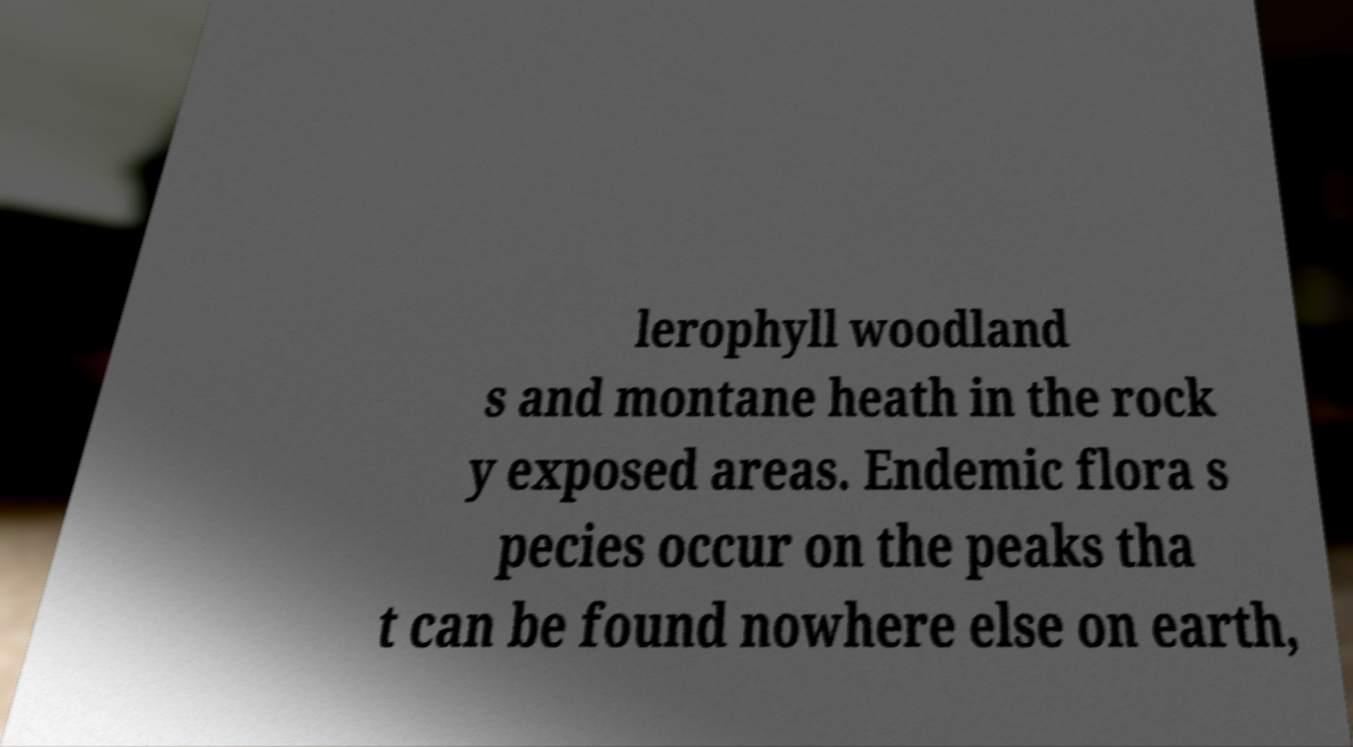For documentation purposes, I need the text within this image transcribed. Could you provide that? lerophyll woodland s and montane heath in the rock y exposed areas. Endemic flora s pecies occur on the peaks tha t can be found nowhere else on earth, 